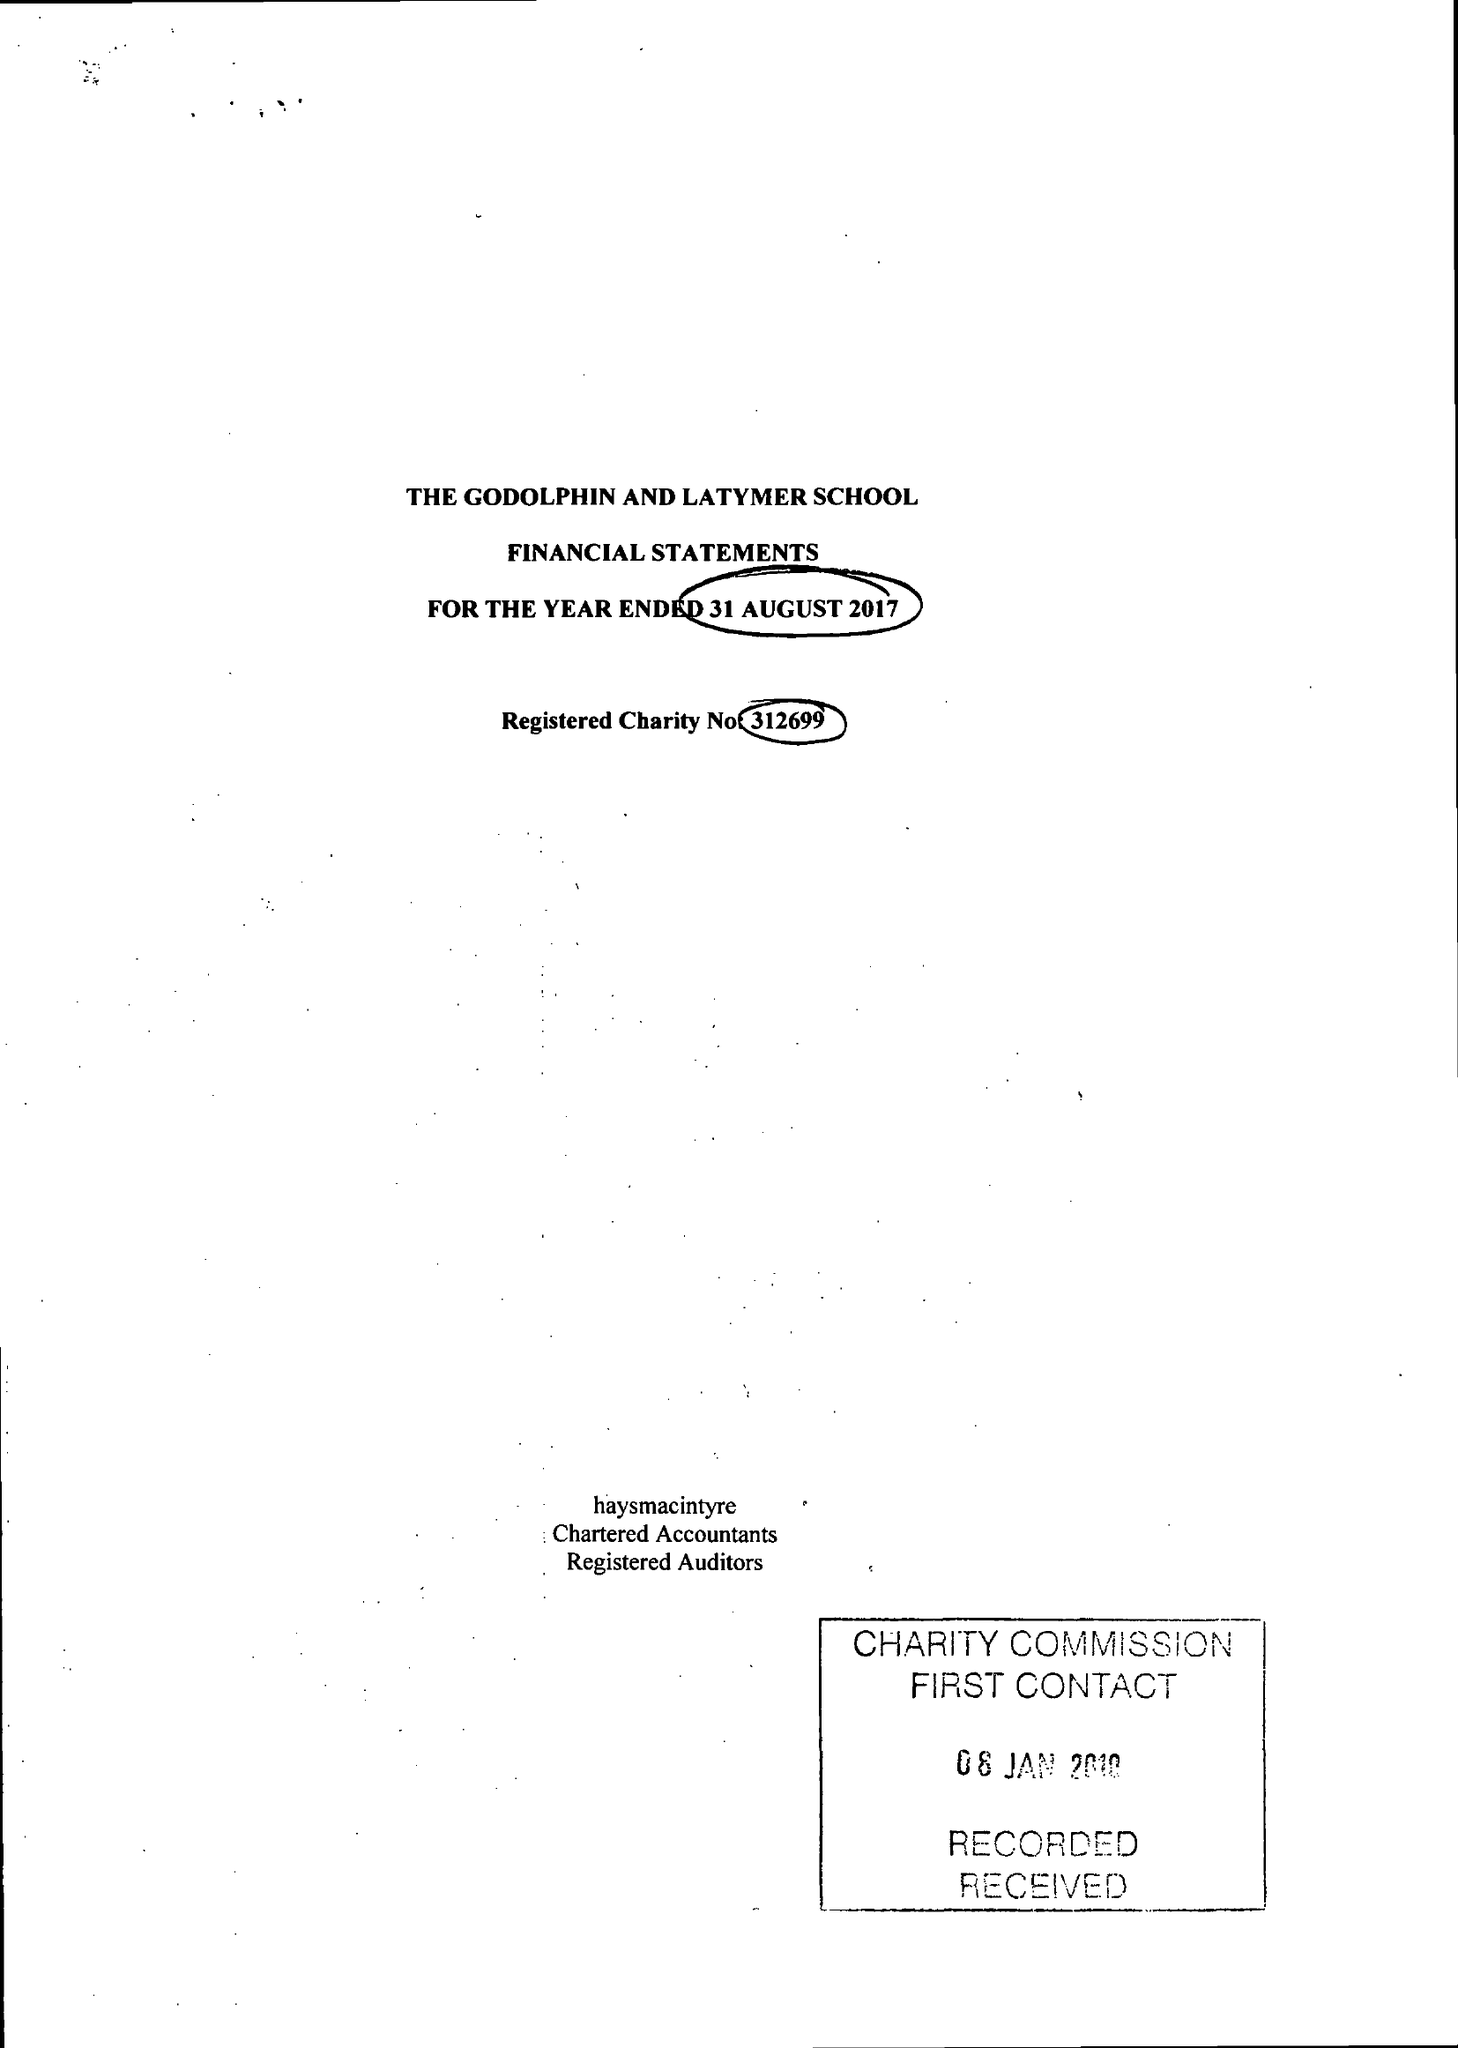What is the value for the address__post_town?
Answer the question using a single word or phrase. LONDON 